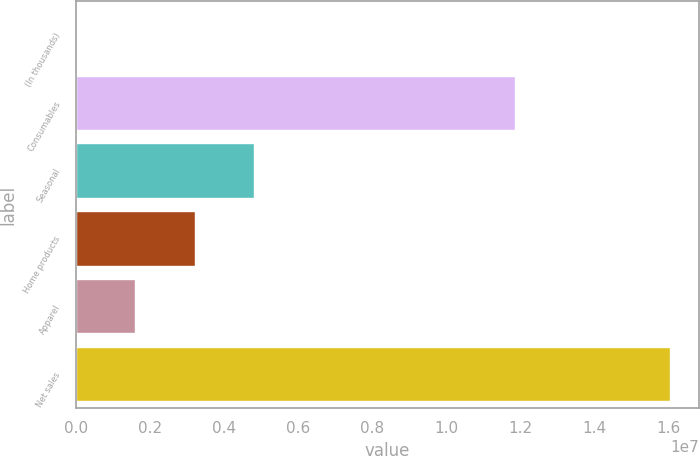Convert chart. <chart><loc_0><loc_0><loc_500><loc_500><bar_chart><fcel>(In thousands)<fcel>Consumables<fcel>Seasonal<fcel>Home products<fcel>Apparel<fcel>Net sales<nl><fcel>2012<fcel>1.18448e+07<fcel>4.80805e+06<fcel>3.20604e+06<fcel>1.60402e+06<fcel>1.60221e+07<nl></chart> 